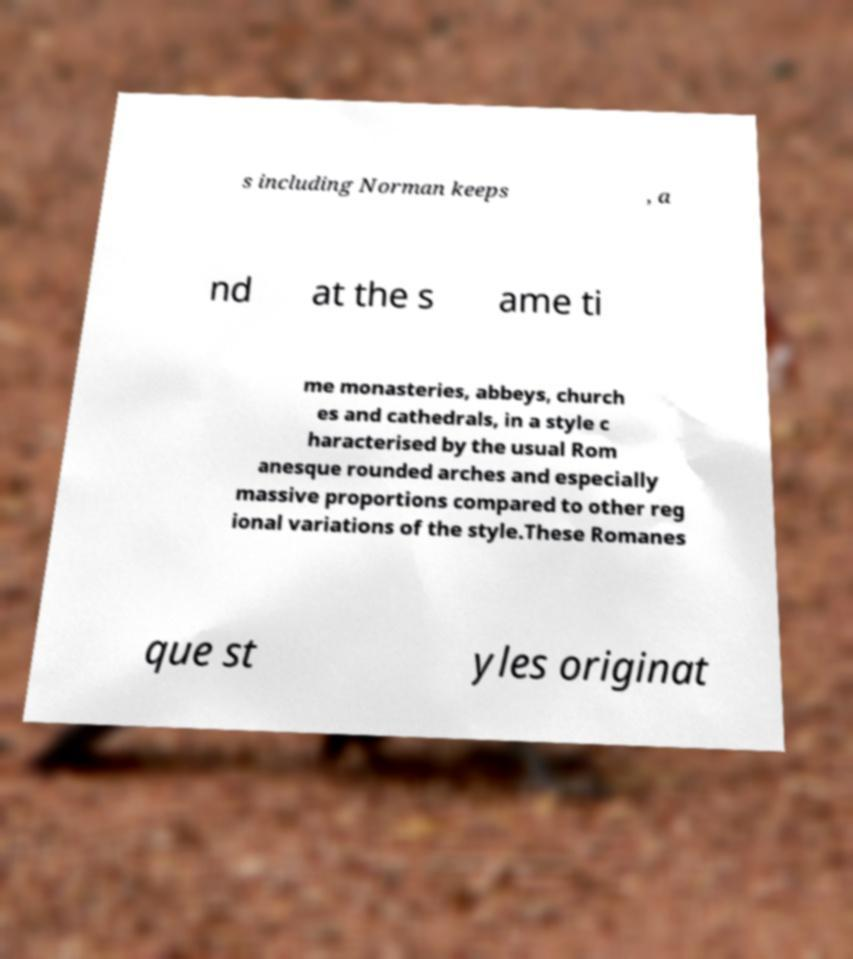Can you accurately transcribe the text from the provided image for me? s including Norman keeps , a nd at the s ame ti me monasteries, abbeys, church es and cathedrals, in a style c haracterised by the usual Rom anesque rounded arches and especially massive proportions compared to other reg ional variations of the style.These Romanes que st yles originat 